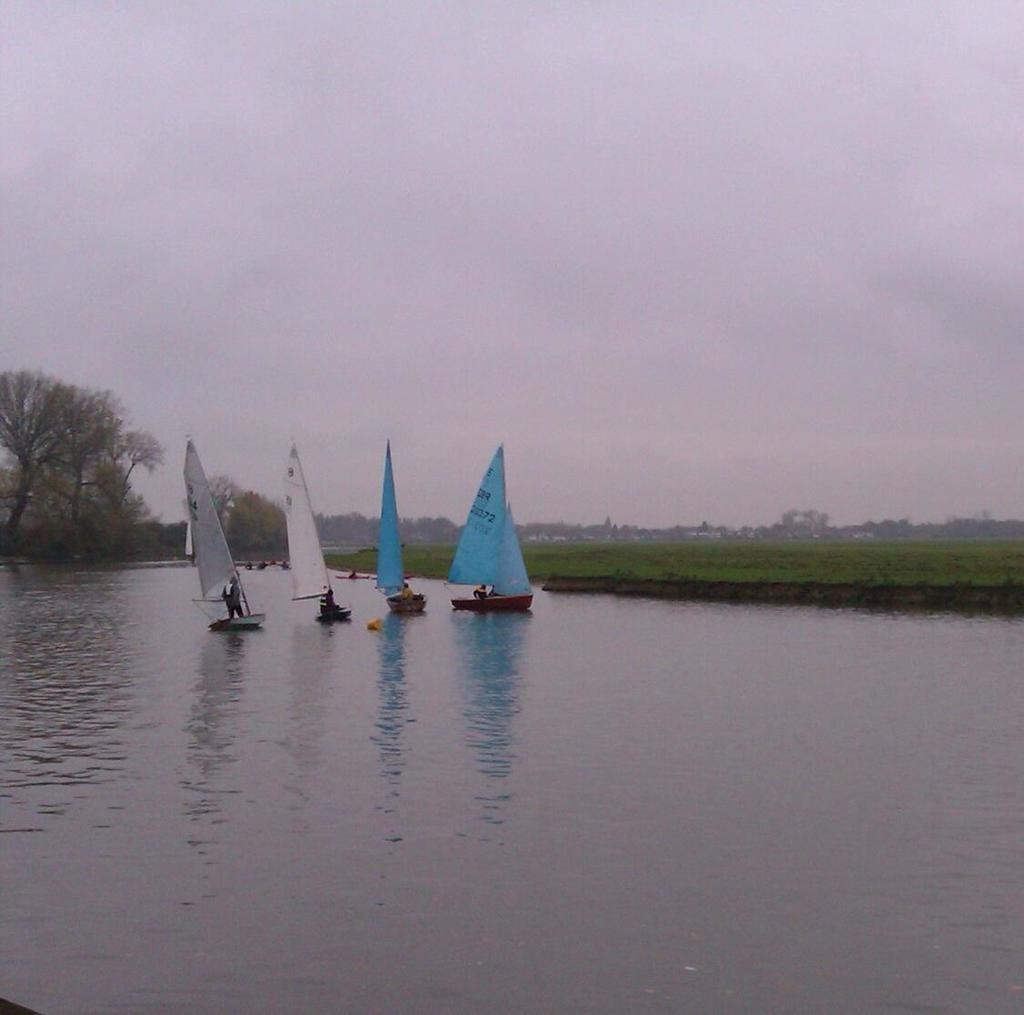What is the main feature of the image? The main feature of the image is water. What is on the water? There are boats on the water. Who is in the boats? There are people in the boats. What can be seen in the background of the image? There are trees and the sky visible in the background of the image. What type of vegetation is present in the image? There is grass in the image. What type of oil can be seen floating on the water in the image? There is no oil visible on the water in the image. What committee is responsible for the maintenance of the boats in the image? There is no information about a committee in the image. 